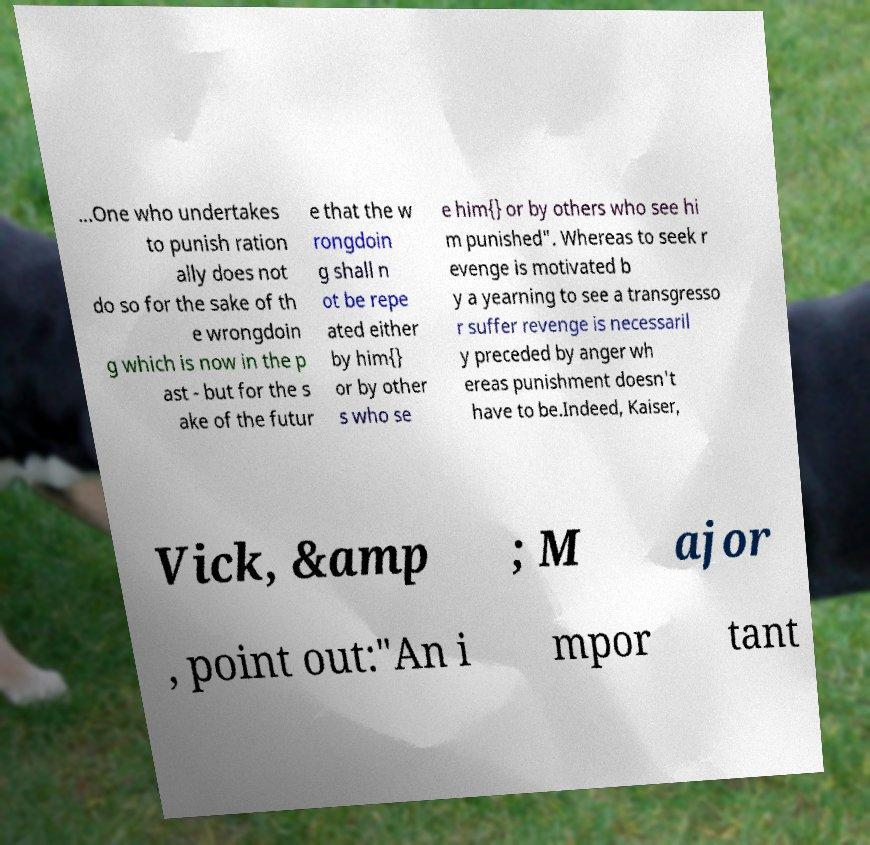I need the written content from this picture converted into text. Can you do that? ...One who undertakes to punish ration ally does not do so for the sake of th e wrongdoin g which is now in the p ast - but for the s ake of the futur e that the w rongdoin g shall n ot be repe ated either by him{} or by other s who se e him{} or by others who see hi m punished". Whereas to seek r evenge is motivated b y a yearning to see a transgresso r suffer revenge is necessaril y preceded by anger wh ereas punishment doesn't have to be.Indeed, Kaiser, Vick, &amp ; M ajor , point out:"An i mpor tant 